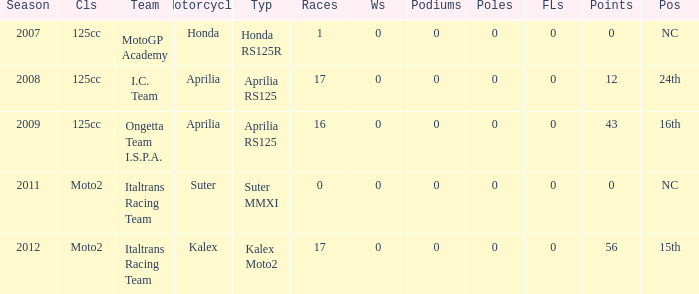What's the name of the team who had a Honda motorcycle? MotoGP Academy. 